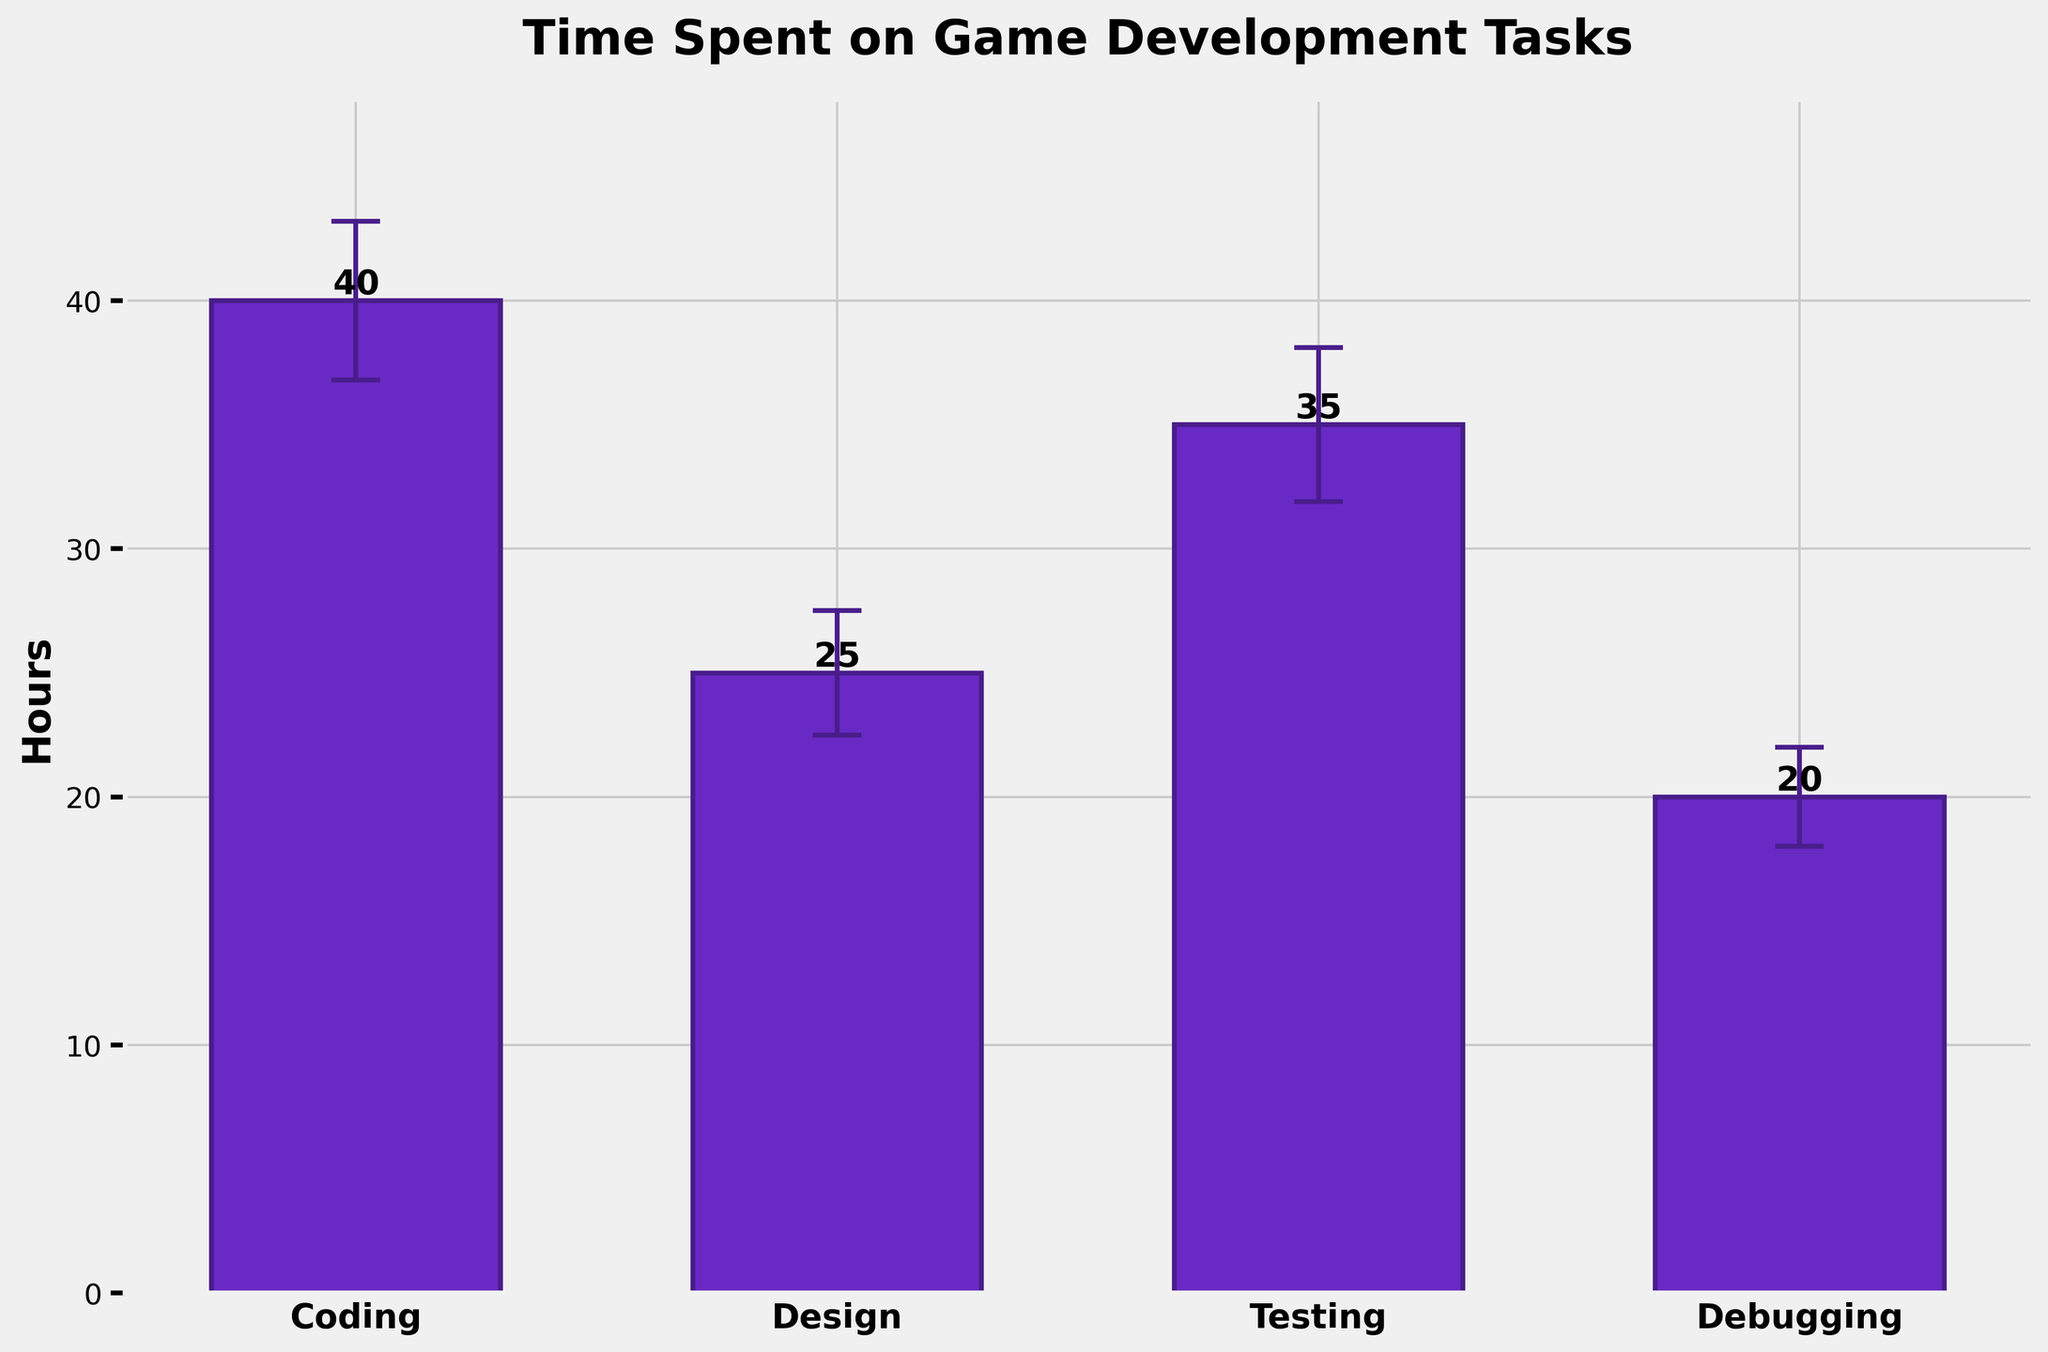What is the title of the figure? The title is displayed at the top of the figure and reads "Time Spent on Game Development Tasks".
Answer: Time Spent on Game Development Tasks How many tasks are displayed in the figure? There are four bars corresponding to the four tasks: Coding, Design, Testing, and Debugging.
Answer: Four Which task has the highest mean hours? The tallest bar represents the highest mean hours. In the figure, the Coding bar is the tallest.
Answer: Coding What is the mean time spent on Debugging? The height of the Debugging bar represents the mean hours, which is labeled directly on the figure as 20 hours.
Answer: 20 hours Which task has the largest standard error? The size of the error bars indicates the standard error; the tallest error bar corresponds to Coding with a standard error of 3.2.
Answer: Coding What is the difference in mean hours between Testing and Design? Subtract the mean hours of Design (25) from Testing (35). So, 35 - 25 = 10.
Answer: 10 hours What is the total time spent on all tasks combined? Sum the mean hours of all tasks: 40 (Coding) + 25 (Design) + 35 (Testing) + 20 (Debugging). The total is 120.
Answer: 120 hours Which task has the lowest mean hours? The shortest bar represents the lowest mean hours. In the figure, the Debugging bar is the shortest.
Answer: Debugging Is the standard error for Testing higher or lower than for Design? Compare the error bars for Testing and Design. The standard error for Testing is 3.1, which is higher than 2.5 for Design.
Answer: Higher By how much is the mean time for Coding greater than the mean time for Debugging? Subtract the mean hours of Debugging (20) from Coding (40). So, 40 - 20 = 20.
Answer: 20 hours 